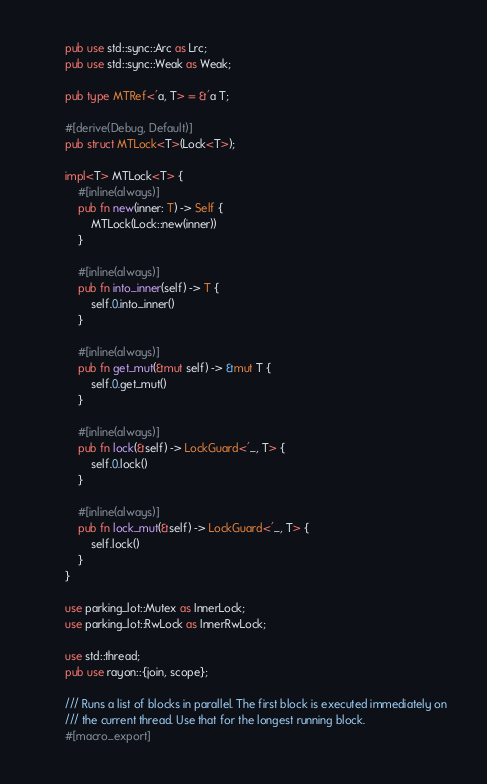Convert code to text. <code><loc_0><loc_0><loc_500><loc_500><_Rust_>        pub use std::sync::Arc as Lrc;
        pub use std::sync::Weak as Weak;

        pub type MTRef<'a, T> = &'a T;

        #[derive(Debug, Default)]
        pub struct MTLock<T>(Lock<T>);

        impl<T> MTLock<T> {
            #[inline(always)]
            pub fn new(inner: T) -> Self {
                MTLock(Lock::new(inner))
            }

            #[inline(always)]
            pub fn into_inner(self) -> T {
                self.0.into_inner()
            }

            #[inline(always)]
            pub fn get_mut(&mut self) -> &mut T {
                self.0.get_mut()
            }

            #[inline(always)]
            pub fn lock(&self) -> LockGuard<'_, T> {
                self.0.lock()
            }

            #[inline(always)]
            pub fn lock_mut(&self) -> LockGuard<'_, T> {
                self.lock()
            }
        }

        use parking_lot::Mutex as InnerLock;
        use parking_lot::RwLock as InnerRwLock;

        use std::thread;
        pub use rayon::{join, scope};

        /// Runs a list of blocks in parallel. The first block is executed immediately on
        /// the current thread. Use that for the longest running block.
        #[macro_export]</code> 